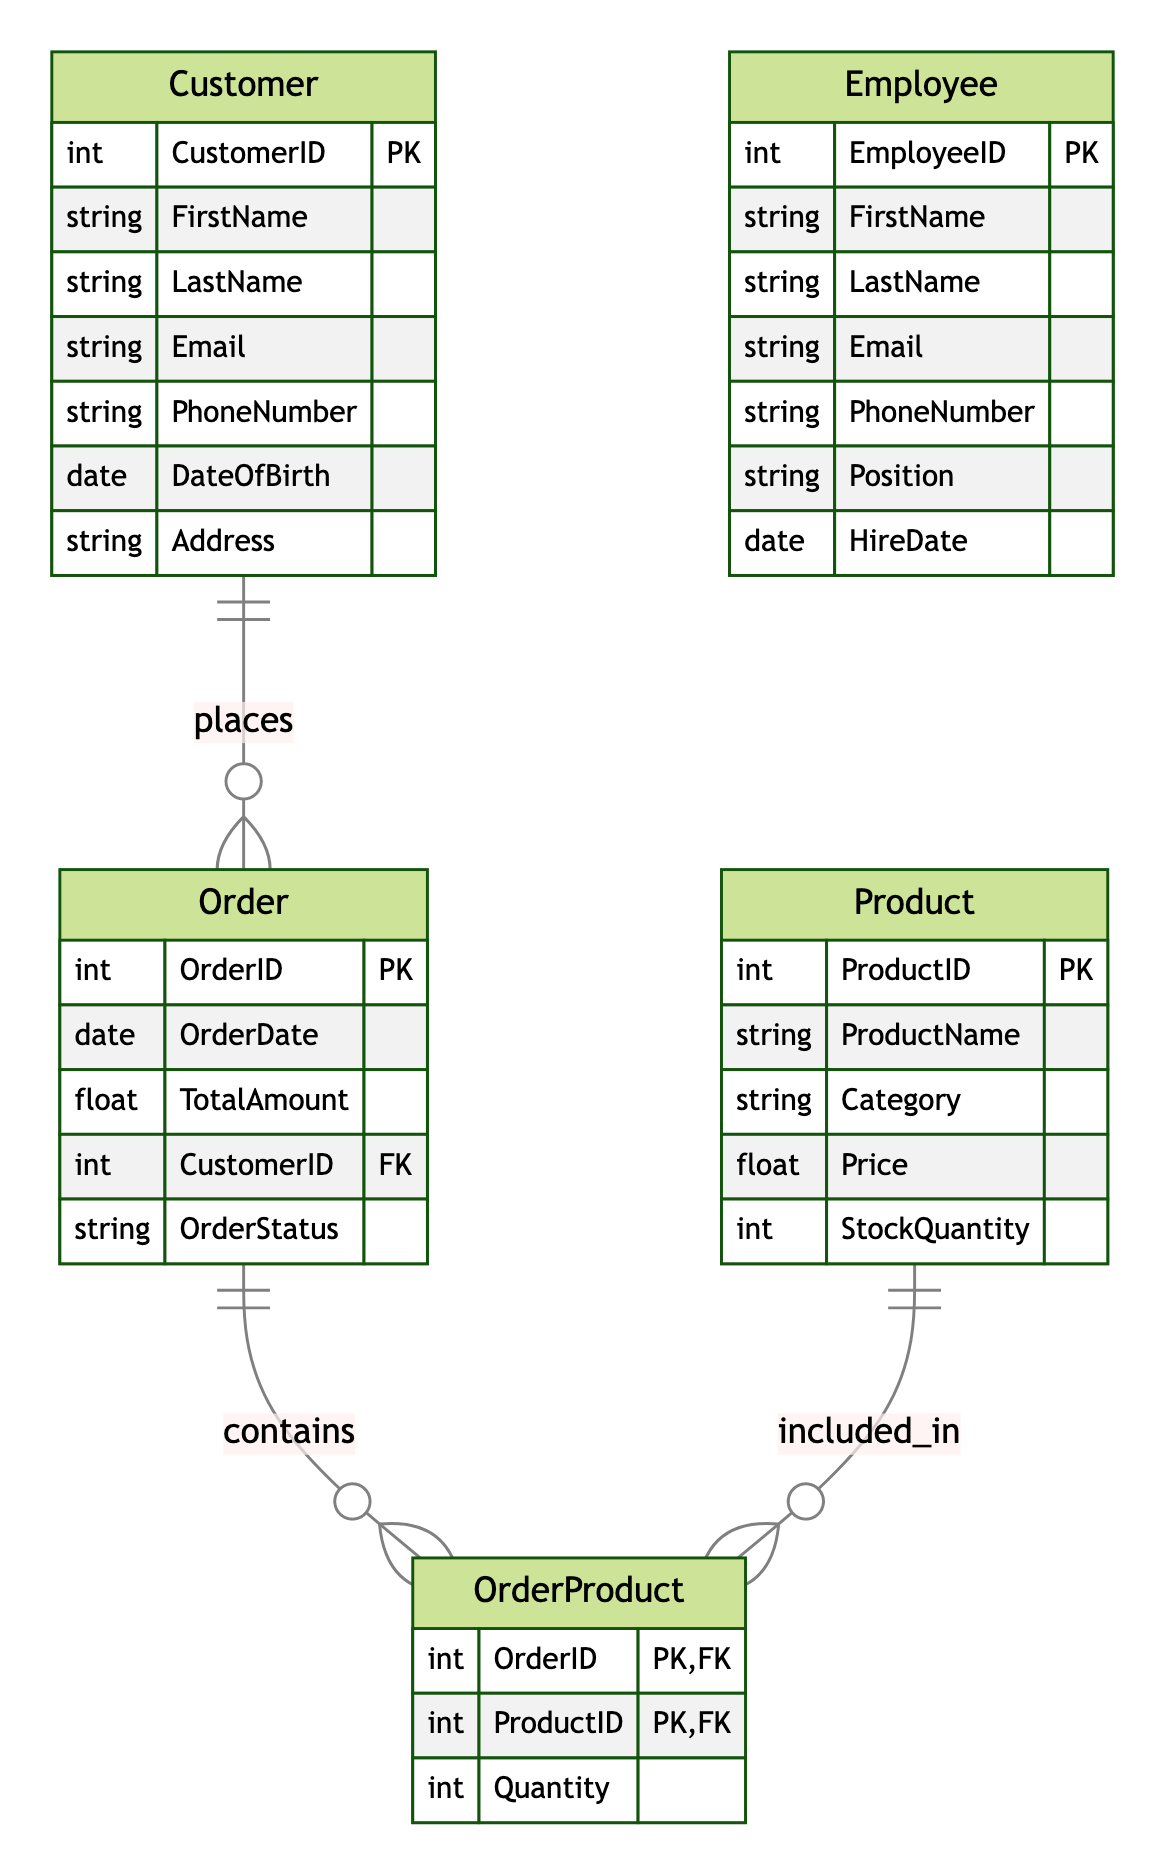What is the primary key of the Customer entity? The primary key for the Customer entity is CustomerID, as specified in the diagram and is essential for uniquely identifying each customer.
Answer: CustomerID How many attributes does the Product entity have? By reviewing the Product entity section of the diagram, we can see it has five attributes: ProductID, ProductName, Category, Price, and StockQuantity. Counting these gives us five.
Answer: Five What type of relationship exists between Customer and Order? The diagram indicates a One-to-Many relationship between Customer and Order, meaning that one customer can place many orders.
Answer: One-to-Many Which entity is associated with the OrderProduct entity? The diagram shows that both the Order and Product entities are directly related to OrderProduct,, as they provide the foreign keys OrderID and ProductID.
Answer: Order, Product What is the foreign key in the Order entity? The foreign key in the Order entity is CustomerID, which links each order to the customer who placed it, illustrating how customers and orders are related in the database.
Answer: CustomerID How many entities are represented in the diagram? Counting the entities listed in the diagram, there are five entities: Customer, Order, Product, OrderProduct, and Employee, resulting in a total of five entities.
Answer: Five What does the OrderProduct entity represent? OrderProduct serves as a join table that captures the details of products included in each order, with the primary keys OrderID and ProductID linking the relationship between these two entities.
Answer: Join table How many orders can a single customer have? Since there is a One-to-Many relationship between Customer and Order, a single customer can have multiple orders. The exact number is not defined in the diagram but is typically treated as many.
Answer: Many What is the relationship between Product and OrderProduct? The diagram specifies a One-to-Many relationship from Product to OrderProduct, indicating that one product can appear in many order records.
Answer: One-to-Many 